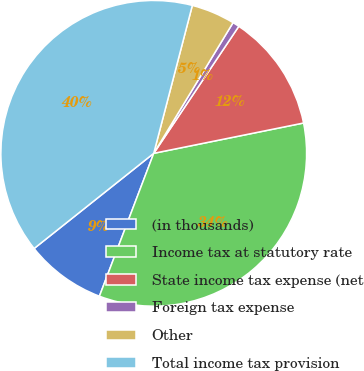Convert chart. <chart><loc_0><loc_0><loc_500><loc_500><pie_chart><fcel>(in thousands)<fcel>Income tax at statutory rate<fcel>State income tax expense (net<fcel>Foreign tax expense<fcel>Other<fcel>Total income tax provision<nl><fcel>8.52%<fcel>33.96%<fcel>12.43%<fcel>0.71%<fcel>4.62%<fcel>39.76%<nl></chart> 